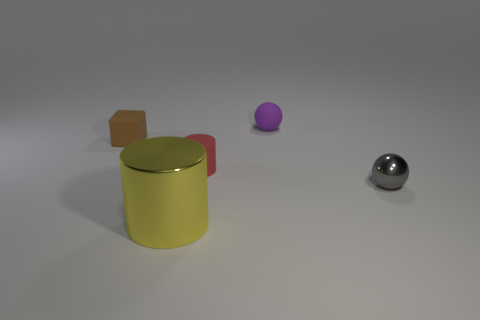Subtract all purple spheres. How many spheres are left? 1 Subtract all brown cylinders. How many red spheres are left? 0 Subtract all small gray shiny things. Subtract all gray balls. How many objects are left? 3 Add 2 purple balls. How many purple balls are left? 3 Add 1 large gray matte cubes. How many large gray matte cubes exist? 1 Add 1 tiny gray spheres. How many objects exist? 6 Subtract 1 purple spheres. How many objects are left? 4 Subtract all balls. How many objects are left? 3 Subtract 2 cylinders. How many cylinders are left? 0 Subtract all gray cylinders. Subtract all yellow balls. How many cylinders are left? 2 